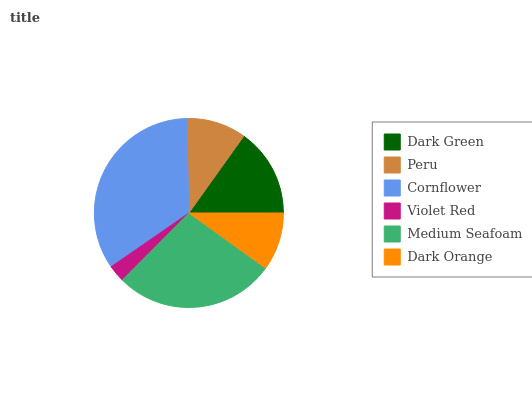Is Violet Red the minimum?
Answer yes or no. Yes. Is Cornflower the maximum?
Answer yes or no. Yes. Is Peru the minimum?
Answer yes or no. No. Is Peru the maximum?
Answer yes or no. No. Is Dark Green greater than Peru?
Answer yes or no. Yes. Is Peru less than Dark Green?
Answer yes or no. Yes. Is Peru greater than Dark Green?
Answer yes or no. No. Is Dark Green less than Peru?
Answer yes or no. No. Is Dark Green the high median?
Answer yes or no. Yes. Is Peru the low median?
Answer yes or no. Yes. Is Violet Red the high median?
Answer yes or no. No. Is Dark Orange the low median?
Answer yes or no. No. 